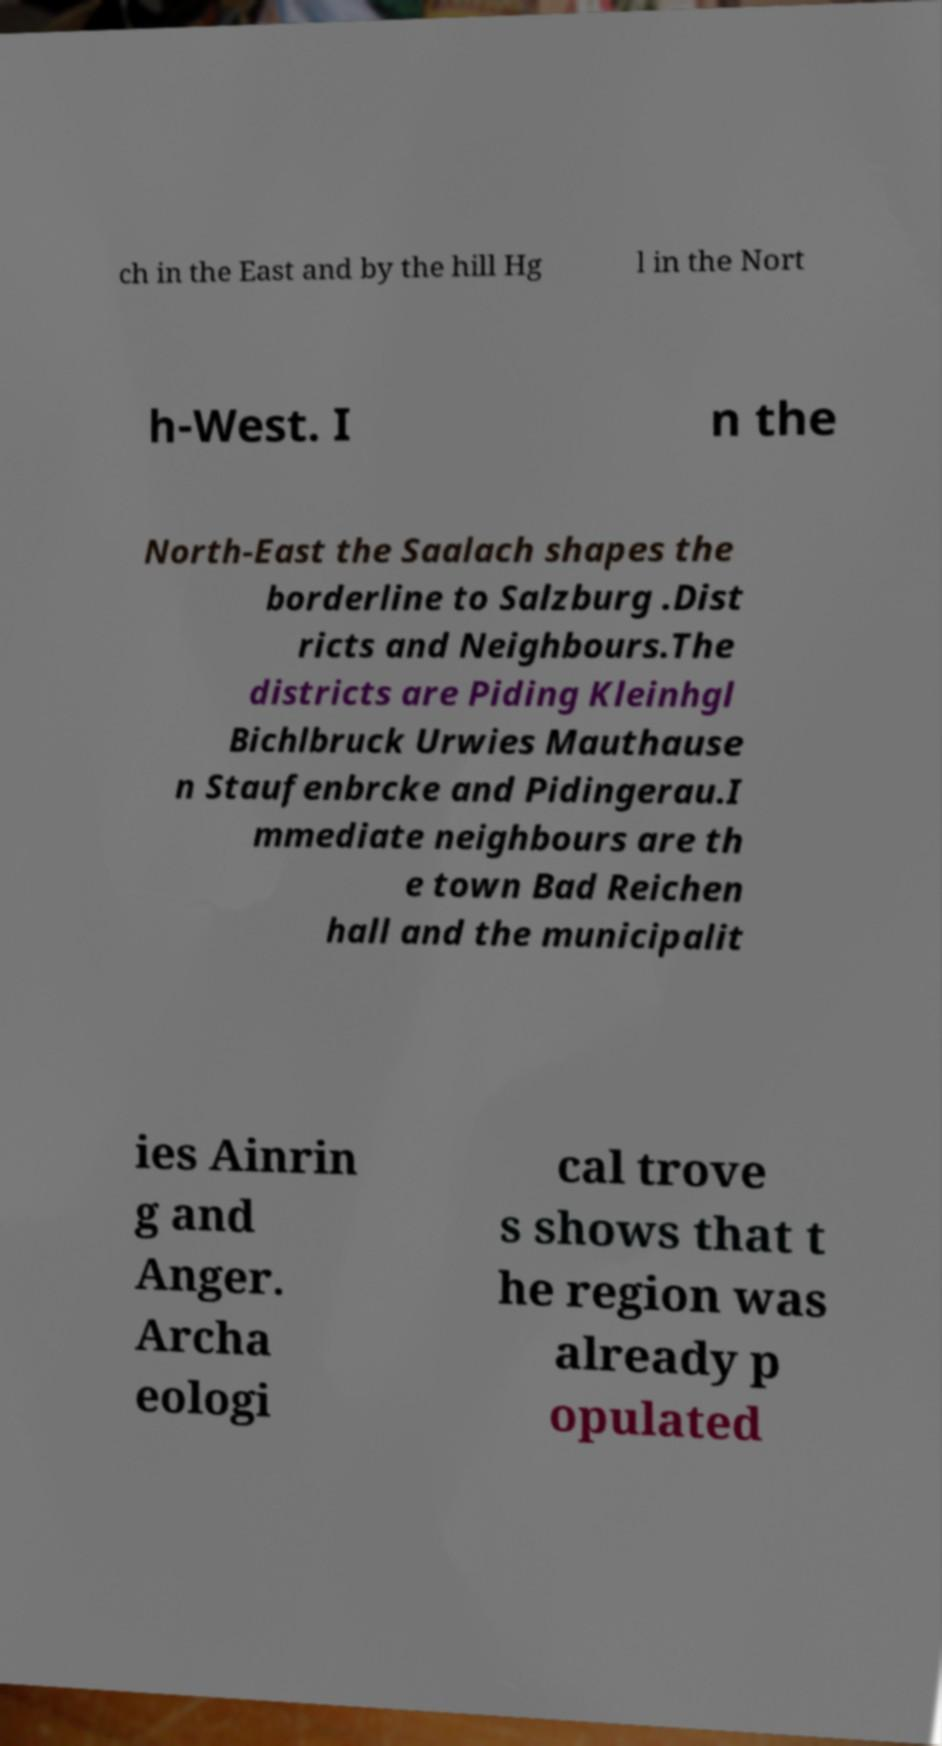For documentation purposes, I need the text within this image transcribed. Could you provide that? ch in the East and by the hill Hg l in the Nort h-West. I n the North-East the Saalach shapes the borderline to Salzburg .Dist ricts and Neighbours.The districts are Piding Kleinhgl Bichlbruck Urwies Mauthause n Staufenbrcke and Pidingerau.I mmediate neighbours are th e town Bad Reichen hall and the municipalit ies Ainrin g and Anger. Archa eologi cal trove s shows that t he region was already p opulated 